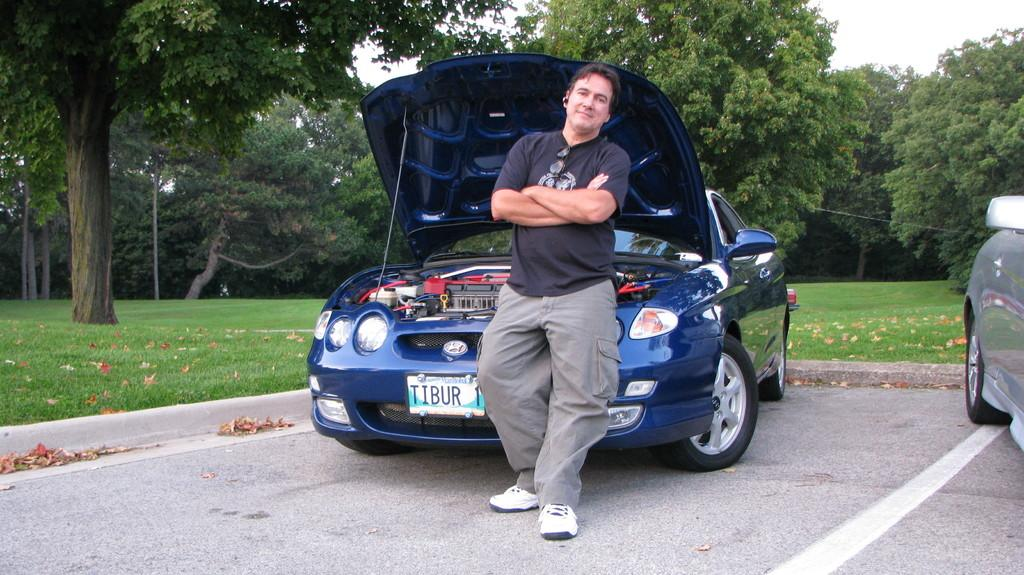How many cars are in the image? There are two cars in the image. What is the person in the image doing? The person is standing on the road. What type of vegetation can be seen in the background of the image? There are trees and leaves present in the background of the image. What else can be seen in the background of the image? There is grass, a wire, and the sky visible in the background of the image. Can you describe the setting where the image might have been taken? The image may have been taken in a park, given the presence of trees, grass, and the open road. What type of thunder can be heard in the image? There is no sound present in the image, so it is not possible to determine if there is any thunder. 